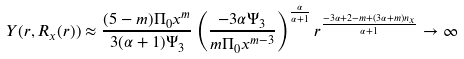<formula> <loc_0><loc_0><loc_500><loc_500>Y ( r , R _ { x } ( r ) ) \approx \frac { ( 5 - m ) \Pi _ { 0 } x ^ { m } } { 3 ( \alpha + 1 ) \Psi _ { 3 } } \left ( \frac { - 3 \alpha \Psi _ { 3 } } { m \Pi _ { 0 } x ^ { m - 3 } } \right ) ^ { \frac { \alpha } { \alpha + 1 } } r ^ { \frac { - 3 \alpha + 2 - m + ( 3 \alpha + m ) n _ { x } } { \alpha + 1 } } \to \infty</formula> 